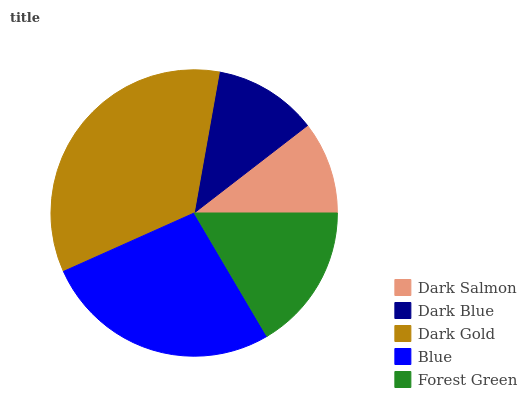Is Dark Salmon the minimum?
Answer yes or no. Yes. Is Dark Gold the maximum?
Answer yes or no. Yes. Is Dark Blue the minimum?
Answer yes or no. No. Is Dark Blue the maximum?
Answer yes or no. No. Is Dark Blue greater than Dark Salmon?
Answer yes or no. Yes. Is Dark Salmon less than Dark Blue?
Answer yes or no. Yes. Is Dark Salmon greater than Dark Blue?
Answer yes or no. No. Is Dark Blue less than Dark Salmon?
Answer yes or no. No. Is Forest Green the high median?
Answer yes or no. Yes. Is Forest Green the low median?
Answer yes or no. Yes. Is Dark Blue the high median?
Answer yes or no. No. Is Blue the low median?
Answer yes or no. No. 